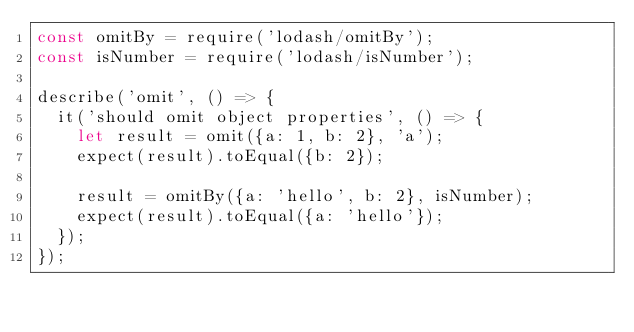<code> <loc_0><loc_0><loc_500><loc_500><_JavaScript_>const omitBy = require('lodash/omitBy');
const isNumber = require('lodash/isNumber');

describe('omit', () => {
  it('should omit object properties', () => {
    let result = omit({a: 1, b: 2}, 'a');
    expect(result).toEqual({b: 2});

    result = omitBy({a: 'hello', b: 2}, isNumber);
    expect(result).toEqual({a: 'hello'});
  });
});</code> 